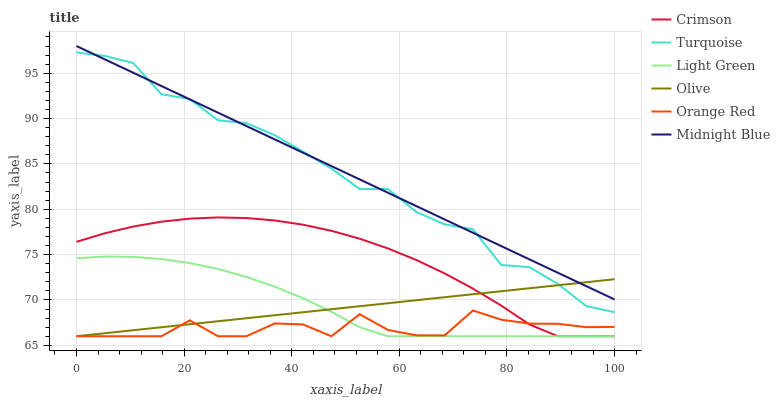Does Orange Red have the minimum area under the curve?
Answer yes or no. Yes. Does Midnight Blue have the maximum area under the curve?
Answer yes or no. Yes. Does Olive have the minimum area under the curve?
Answer yes or no. No. Does Olive have the maximum area under the curve?
Answer yes or no. No. Is Midnight Blue the smoothest?
Answer yes or no. Yes. Is Turquoise the roughest?
Answer yes or no. Yes. Is Olive the smoothest?
Answer yes or no. No. Is Olive the roughest?
Answer yes or no. No. Does Olive have the lowest value?
Answer yes or no. Yes. Does Midnight Blue have the lowest value?
Answer yes or no. No. Does Midnight Blue have the highest value?
Answer yes or no. Yes. Does Olive have the highest value?
Answer yes or no. No. Is Light Green less than Midnight Blue?
Answer yes or no. Yes. Is Turquoise greater than Light Green?
Answer yes or no. Yes. Does Crimson intersect Orange Red?
Answer yes or no. Yes. Is Crimson less than Orange Red?
Answer yes or no. No. Is Crimson greater than Orange Red?
Answer yes or no. No. Does Light Green intersect Midnight Blue?
Answer yes or no. No. 